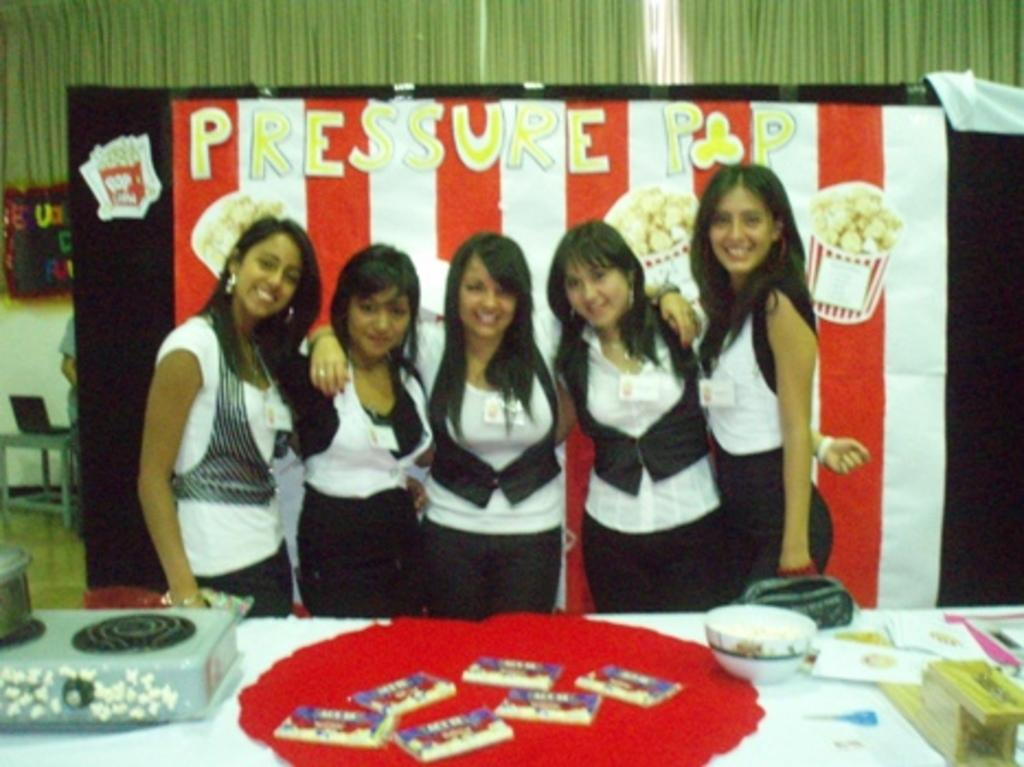What is the main subject of the image? There is a group of girls in the image. Where are the girls positioned in relation to the table? The girls are standing in front of a table. What type of food can be seen on the table? There are chocolates on the table. Are there any other items on the table besides chocolates? Yes, there are other objects on the table. What can be seen in the background of the image? There is a banner in the background of the image. What type of spade is being used by the girls in the image? There is no spade present in the image; the girls are not using any tools or equipment. Can you tell me how many toothbrushes are visible in the image? There are no toothbrushes present in the image. 